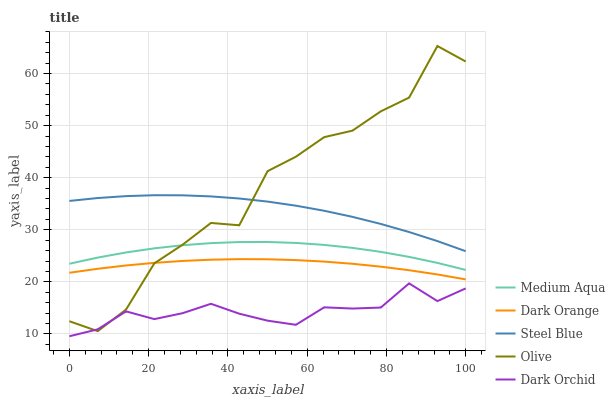Does Dark Orchid have the minimum area under the curve?
Answer yes or no. Yes. Does Olive have the maximum area under the curve?
Answer yes or no. Yes. Does Dark Orange have the minimum area under the curve?
Answer yes or no. No. Does Dark Orange have the maximum area under the curve?
Answer yes or no. No. Is Dark Orange the smoothest?
Answer yes or no. Yes. Is Olive the roughest?
Answer yes or no. Yes. Is Medium Aqua the smoothest?
Answer yes or no. No. Is Medium Aqua the roughest?
Answer yes or no. No. Does Dark Orange have the lowest value?
Answer yes or no. No. Does Olive have the highest value?
Answer yes or no. Yes. Does Dark Orange have the highest value?
Answer yes or no. No. Is Medium Aqua less than Steel Blue?
Answer yes or no. Yes. Is Medium Aqua greater than Dark Orchid?
Answer yes or no. Yes. Does Olive intersect Dark Orange?
Answer yes or no. Yes. Is Olive less than Dark Orange?
Answer yes or no. No. Is Olive greater than Dark Orange?
Answer yes or no. No. Does Medium Aqua intersect Steel Blue?
Answer yes or no. No. 